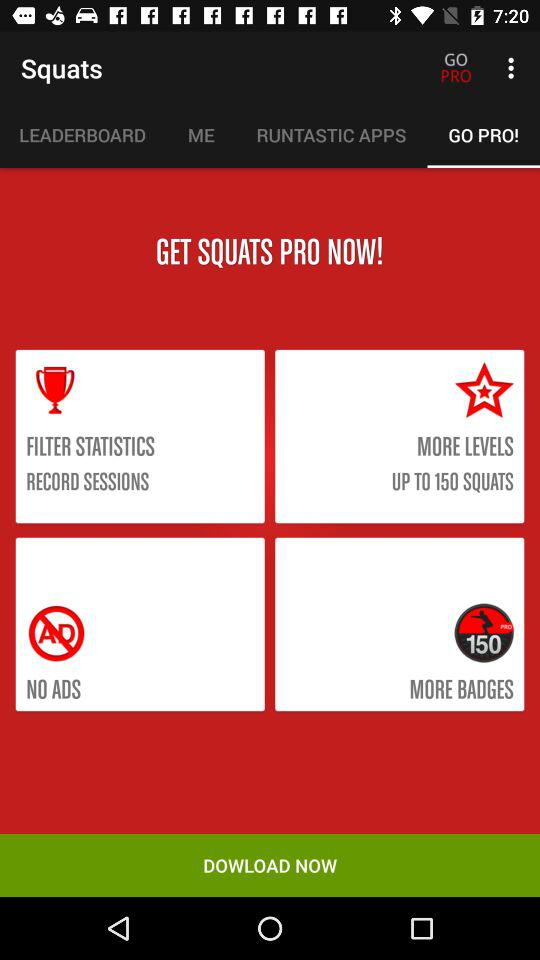Which tab is selected? The selected tab is "GO PRO!". 